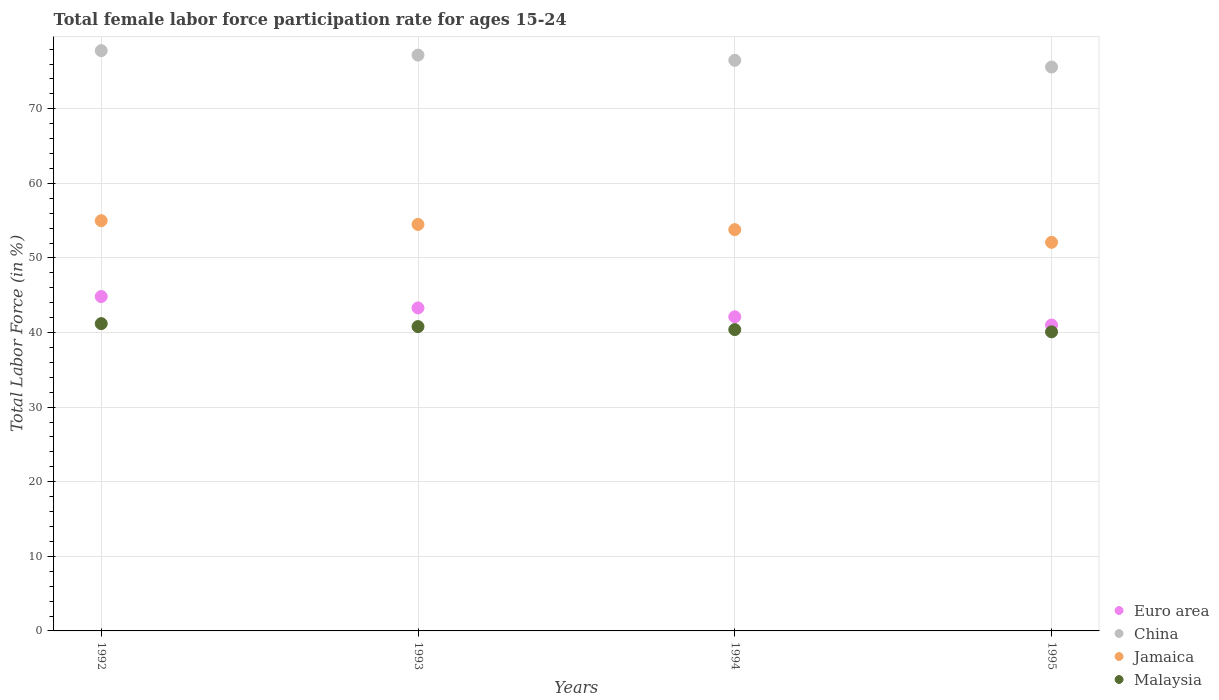What is the female labor force participation rate in China in 1994?
Ensure brevity in your answer.  76.5. Across all years, what is the maximum female labor force participation rate in China?
Offer a very short reply. 77.8. Across all years, what is the minimum female labor force participation rate in Euro area?
Offer a very short reply. 41.01. In which year was the female labor force participation rate in Euro area minimum?
Provide a succinct answer. 1995. What is the total female labor force participation rate in China in the graph?
Offer a very short reply. 307.1. What is the difference between the female labor force participation rate in Jamaica in 1994 and that in 1995?
Make the answer very short. 1.7. What is the difference between the female labor force participation rate in Euro area in 1993 and the female labor force participation rate in China in 1992?
Give a very brief answer. -34.49. What is the average female labor force participation rate in Jamaica per year?
Provide a succinct answer. 53.85. In the year 1992, what is the difference between the female labor force participation rate in Jamaica and female labor force participation rate in China?
Offer a very short reply. -22.8. In how many years, is the female labor force participation rate in China greater than 42 %?
Your response must be concise. 4. What is the ratio of the female labor force participation rate in Euro area in 1993 to that in 1994?
Your response must be concise. 1.03. Is the difference between the female labor force participation rate in Jamaica in 1993 and 1994 greater than the difference between the female labor force participation rate in China in 1993 and 1994?
Your answer should be very brief. Yes. What is the difference between the highest and the second highest female labor force participation rate in Euro area?
Make the answer very short. 1.52. What is the difference between the highest and the lowest female labor force participation rate in Euro area?
Offer a very short reply. 3.82. In how many years, is the female labor force participation rate in Jamaica greater than the average female labor force participation rate in Jamaica taken over all years?
Your answer should be compact. 2. Is the sum of the female labor force participation rate in China in 1994 and 1995 greater than the maximum female labor force participation rate in Malaysia across all years?
Keep it short and to the point. Yes. Is it the case that in every year, the sum of the female labor force participation rate in Euro area and female labor force participation rate in China  is greater than the sum of female labor force participation rate in Jamaica and female labor force participation rate in Malaysia?
Your response must be concise. No. Is the female labor force participation rate in Malaysia strictly greater than the female labor force participation rate in Euro area over the years?
Your answer should be very brief. No. How many years are there in the graph?
Provide a succinct answer. 4. What is the difference between two consecutive major ticks on the Y-axis?
Your answer should be compact. 10. Where does the legend appear in the graph?
Ensure brevity in your answer.  Bottom right. How are the legend labels stacked?
Provide a succinct answer. Vertical. What is the title of the graph?
Keep it short and to the point. Total female labor force participation rate for ages 15-24. Does "Cote d'Ivoire" appear as one of the legend labels in the graph?
Give a very brief answer. No. What is the Total Labor Force (in %) of Euro area in 1992?
Your answer should be very brief. 44.83. What is the Total Labor Force (in %) in China in 1992?
Provide a short and direct response. 77.8. What is the Total Labor Force (in %) in Malaysia in 1992?
Provide a short and direct response. 41.2. What is the Total Labor Force (in %) in Euro area in 1993?
Your answer should be very brief. 43.31. What is the Total Labor Force (in %) in China in 1993?
Keep it short and to the point. 77.2. What is the Total Labor Force (in %) of Jamaica in 1993?
Your answer should be compact. 54.5. What is the Total Labor Force (in %) of Malaysia in 1993?
Make the answer very short. 40.8. What is the Total Labor Force (in %) in Euro area in 1994?
Your response must be concise. 42.11. What is the Total Labor Force (in %) in China in 1994?
Provide a succinct answer. 76.5. What is the Total Labor Force (in %) of Jamaica in 1994?
Your answer should be very brief. 53.8. What is the Total Labor Force (in %) in Malaysia in 1994?
Keep it short and to the point. 40.4. What is the Total Labor Force (in %) in Euro area in 1995?
Offer a very short reply. 41.01. What is the Total Labor Force (in %) in China in 1995?
Your response must be concise. 75.6. What is the Total Labor Force (in %) in Jamaica in 1995?
Offer a terse response. 52.1. What is the Total Labor Force (in %) in Malaysia in 1995?
Provide a succinct answer. 40.1. Across all years, what is the maximum Total Labor Force (in %) in Euro area?
Your answer should be very brief. 44.83. Across all years, what is the maximum Total Labor Force (in %) in China?
Your answer should be very brief. 77.8. Across all years, what is the maximum Total Labor Force (in %) in Malaysia?
Make the answer very short. 41.2. Across all years, what is the minimum Total Labor Force (in %) in Euro area?
Your answer should be very brief. 41.01. Across all years, what is the minimum Total Labor Force (in %) of China?
Your answer should be compact. 75.6. Across all years, what is the minimum Total Labor Force (in %) in Jamaica?
Provide a short and direct response. 52.1. Across all years, what is the minimum Total Labor Force (in %) of Malaysia?
Keep it short and to the point. 40.1. What is the total Total Labor Force (in %) of Euro area in the graph?
Ensure brevity in your answer.  171.26. What is the total Total Labor Force (in %) in China in the graph?
Your answer should be very brief. 307.1. What is the total Total Labor Force (in %) in Jamaica in the graph?
Make the answer very short. 215.4. What is the total Total Labor Force (in %) of Malaysia in the graph?
Your answer should be very brief. 162.5. What is the difference between the Total Labor Force (in %) of Euro area in 1992 and that in 1993?
Provide a short and direct response. 1.52. What is the difference between the Total Labor Force (in %) in China in 1992 and that in 1993?
Ensure brevity in your answer.  0.6. What is the difference between the Total Labor Force (in %) of Jamaica in 1992 and that in 1993?
Give a very brief answer. 0.5. What is the difference between the Total Labor Force (in %) of Malaysia in 1992 and that in 1993?
Offer a very short reply. 0.4. What is the difference between the Total Labor Force (in %) of Euro area in 1992 and that in 1994?
Give a very brief answer. 2.72. What is the difference between the Total Labor Force (in %) in China in 1992 and that in 1994?
Ensure brevity in your answer.  1.3. What is the difference between the Total Labor Force (in %) in Jamaica in 1992 and that in 1994?
Provide a succinct answer. 1.2. What is the difference between the Total Labor Force (in %) in Euro area in 1992 and that in 1995?
Make the answer very short. 3.82. What is the difference between the Total Labor Force (in %) in China in 1992 and that in 1995?
Provide a short and direct response. 2.2. What is the difference between the Total Labor Force (in %) in Euro area in 1993 and that in 1994?
Give a very brief answer. 1.19. What is the difference between the Total Labor Force (in %) of China in 1993 and that in 1994?
Offer a very short reply. 0.7. What is the difference between the Total Labor Force (in %) of Jamaica in 1993 and that in 1994?
Your response must be concise. 0.7. What is the difference between the Total Labor Force (in %) in Malaysia in 1993 and that in 1994?
Keep it short and to the point. 0.4. What is the difference between the Total Labor Force (in %) in Euro area in 1993 and that in 1995?
Your answer should be compact. 2.29. What is the difference between the Total Labor Force (in %) of Jamaica in 1993 and that in 1995?
Keep it short and to the point. 2.4. What is the difference between the Total Labor Force (in %) of Euro area in 1994 and that in 1995?
Keep it short and to the point. 1.1. What is the difference between the Total Labor Force (in %) of China in 1994 and that in 1995?
Offer a very short reply. 0.9. What is the difference between the Total Labor Force (in %) of Malaysia in 1994 and that in 1995?
Make the answer very short. 0.3. What is the difference between the Total Labor Force (in %) in Euro area in 1992 and the Total Labor Force (in %) in China in 1993?
Keep it short and to the point. -32.37. What is the difference between the Total Labor Force (in %) in Euro area in 1992 and the Total Labor Force (in %) in Jamaica in 1993?
Give a very brief answer. -9.67. What is the difference between the Total Labor Force (in %) of Euro area in 1992 and the Total Labor Force (in %) of Malaysia in 1993?
Your answer should be very brief. 4.03. What is the difference between the Total Labor Force (in %) of China in 1992 and the Total Labor Force (in %) of Jamaica in 1993?
Provide a short and direct response. 23.3. What is the difference between the Total Labor Force (in %) in China in 1992 and the Total Labor Force (in %) in Malaysia in 1993?
Your answer should be very brief. 37. What is the difference between the Total Labor Force (in %) of Euro area in 1992 and the Total Labor Force (in %) of China in 1994?
Your response must be concise. -31.67. What is the difference between the Total Labor Force (in %) of Euro area in 1992 and the Total Labor Force (in %) of Jamaica in 1994?
Offer a very short reply. -8.97. What is the difference between the Total Labor Force (in %) in Euro area in 1992 and the Total Labor Force (in %) in Malaysia in 1994?
Provide a short and direct response. 4.43. What is the difference between the Total Labor Force (in %) in China in 1992 and the Total Labor Force (in %) in Jamaica in 1994?
Offer a terse response. 24. What is the difference between the Total Labor Force (in %) in China in 1992 and the Total Labor Force (in %) in Malaysia in 1994?
Provide a succinct answer. 37.4. What is the difference between the Total Labor Force (in %) in Euro area in 1992 and the Total Labor Force (in %) in China in 1995?
Your response must be concise. -30.77. What is the difference between the Total Labor Force (in %) in Euro area in 1992 and the Total Labor Force (in %) in Jamaica in 1995?
Provide a succinct answer. -7.27. What is the difference between the Total Labor Force (in %) of Euro area in 1992 and the Total Labor Force (in %) of Malaysia in 1995?
Provide a succinct answer. 4.73. What is the difference between the Total Labor Force (in %) in China in 1992 and the Total Labor Force (in %) in Jamaica in 1995?
Offer a terse response. 25.7. What is the difference between the Total Labor Force (in %) in China in 1992 and the Total Labor Force (in %) in Malaysia in 1995?
Ensure brevity in your answer.  37.7. What is the difference between the Total Labor Force (in %) of Euro area in 1993 and the Total Labor Force (in %) of China in 1994?
Ensure brevity in your answer.  -33.19. What is the difference between the Total Labor Force (in %) in Euro area in 1993 and the Total Labor Force (in %) in Jamaica in 1994?
Your answer should be compact. -10.49. What is the difference between the Total Labor Force (in %) of Euro area in 1993 and the Total Labor Force (in %) of Malaysia in 1994?
Provide a short and direct response. 2.91. What is the difference between the Total Labor Force (in %) in China in 1993 and the Total Labor Force (in %) in Jamaica in 1994?
Ensure brevity in your answer.  23.4. What is the difference between the Total Labor Force (in %) in China in 1993 and the Total Labor Force (in %) in Malaysia in 1994?
Your answer should be very brief. 36.8. What is the difference between the Total Labor Force (in %) in Euro area in 1993 and the Total Labor Force (in %) in China in 1995?
Offer a terse response. -32.29. What is the difference between the Total Labor Force (in %) in Euro area in 1993 and the Total Labor Force (in %) in Jamaica in 1995?
Ensure brevity in your answer.  -8.79. What is the difference between the Total Labor Force (in %) of Euro area in 1993 and the Total Labor Force (in %) of Malaysia in 1995?
Offer a very short reply. 3.21. What is the difference between the Total Labor Force (in %) of China in 1993 and the Total Labor Force (in %) of Jamaica in 1995?
Keep it short and to the point. 25.1. What is the difference between the Total Labor Force (in %) of China in 1993 and the Total Labor Force (in %) of Malaysia in 1995?
Make the answer very short. 37.1. What is the difference between the Total Labor Force (in %) in Jamaica in 1993 and the Total Labor Force (in %) in Malaysia in 1995?
Make the answer very short. 14.4. What is the difference between the Total Labor Force (in %) of Euro area in 1994 and the Total Labor Force (in %) of China in 1995?
Provide a short and direct response. -33.49. What is the difference between the Total Labor Force (in %) in Euro area in 1994 and the Total Labor Force (in %) in Jamaica in 1995?
Provide a short and direct response. -9.99. What is the difference between the Total Labor Force (in %) of Euro area in 1994 and the Total Labor Force (in %) of Malaysia in 1995?
Your answer should be compact. 2.01. What is the difference between the Total Labor Force (in %) in China in 1994 and the Total Labor Force (in %) in Jamaica in 1995?
Give a very brief answer. 24.4. What is the difference between the Total Labor Force (in %) in China in 1994 and the Total Labor Force (in %) in Malaysia in 1995?
Make the answer very short. 36.4. What is the difference between the Total Labor Force (in %) of Jamaica in 1994 and the Total Labor Force (in %) of Malaysia in 1995?
Your answer should be very brief. 13.7. What is the average Total Labor Force (in %) of Euro area per year?
Provide a short and direct response. 42.82. What is the average Total Labor Force (in %) of China per year?
Offer a very short reply. 76.78. What is the average Total Labor Force (in %) in Jamaica per year?
Your response must be concise. 53.85. What is the average Total Labor Force (in %) of Malaysia per year?
Make the answer very short. 40.62. In the year 1992, what is the difference between the Total Labor Force (in %) in Euro area and Total Labor Force (in %) in China?
Ensure brevity in your answer.  -32.97. In the year 1992, what is the difference between the Total Labor Force (in %) in Euro area and Total Labor Force (in %) in Jamaica?
Keep it short and to the point. -10.17. In the year 1992, what is the difference between the Total Labor Force (in %) of Euro area and Total Labor Force (in %) of Malaysia?
Offer a very short reply. 3.63. In the year 1992, what is the difference between the Total Labor Force (in %) of China and Total Labor Force (in %) of Jamaica?
Offer a very short reply. 22.8. In the year 1992, what is the difference between the Total Labor Force (in %) in China and Total Labor Force (in %) in Malaysia?
Provide a succinct answer. 36.6. In the year 1993, what is the difference between the Total Labor Force (in %) in Euro area and Total Labor Force (in %) in China?
Your answer should be very brief. -33.89. In the year 1993, what is the difference between the Total Labor Force (in %) of Euro area and Total Labor Force (in %) of Jamaica?
Keep it short and to the point. -11.19. In the year 1993, what is the difference between the Total Labor Force (in %) in Euro area and Total Labor Force (in %) in Malaysia?
Provide a short and direct response. 2.51. In the year 1993, what is the difference between the Total Labor Force (in %) in China and Total Labor Force (in %) in Jamaica?
Ensure brevity in your answer.  22.7. In the year 1993, what is the difference between the Total Labor Force (in %) of China and Total Labor Force (in %) of Malaysia?
Give a very brief answer. 36.4. In the year 1993, what is the difference between the Total Labor Force (in %) of Jamaica and Total Labor Force (in %) of Malaysia?
Give a very brief answer. 13.7. In the year 1994, what is the difference between the Total Labor Force (in %) of Euro area and Total Labor Force (in %) of China?
Keep it short and to the point. -34.39. In the year 1994, what is the difference between the Total Labor Force (in %) in Euro area and Total Labor Force (in %) in Jamaica?
Make the answer very short. -11.69. In the year 1994, what is the difference between the Total Labor Force (in %) in Euro area and Total Labor Force (in %) in Malaysia?
Your response must be concise. 1.71. In the year 1994, what is the difference between the Total Labor Force (in %) of China and Total Labor Force (in %) of Jamaica?
Keep it short and to the point. 22.7. In the year 1994, what is the difference between the Total Labor Force (in %) of China and Total Labor Force (in %) of Malaysia?
Your answer should be compact. 36.1. In the year 1995, what is the difference between the Total Labor Force (in %) in Euro area and Total Labor Force (in %) in China?
Give a very brief answer. -34.59. In the year 1995, what is the difference between the Total Labor Force (in %) of Euro area and Total Labor Force (in %) of Jamaica?
Offer a terse response. -11.09. In the year 1995, what is the difference between the Total Labor Force (in %) in Euro area and Total Labor Force (in %) in Malaysia?
Your answer should be compact. 0.91. In the year 1995, what is the difference between the Total Labor Force (in %) of China and Total Labor Force (in %) of Malaysia?
Your response must be concise. 35.5. In the year 1995, what is the difference between the Total Labor Force (in %) in Jamaica and Total Labor Force (in %) in Malaysia?
Provide a short and direct response. 12. What is the ratio of the Total Labor Force (in %) of Euro area in 1992 to that in 1993?
Keep it short and to the point. 1.04. What is the ratio of the Total Labor Force (in %) of China in 1992 to that in 1993?
Provide a short and direct response. 1.01. What is the ratio of the Total Labor Force (in %) of Jamaica in 1992 to that in 1993?
Offer a very short reply. 1.01. What is the ratio of the Total Labor Force (in %) in Malaysia in 1992 to that in 1993?
Offer a very short reply. 1.01. What is the ratio of the Total Labor Force (in %) of Euro area in 1992 to that in 1994?
Your answer should be very brief. 1.06. What is the ratio of the Total Labor Force (in %) in Jamaica in 1992 to that in 1994?
Make the answer very short. 1.02. What is the ratio of the Total Labor Force (in %) in Malaysia in 1992 to that in 1994?
Your answer should be compact. 1.02. What is the ratio of the Total Labor Force (in %) in Euro area in 1992 to that in 1995?
Give a very brief answer. 1.09. What is the ratio of the Total Labor Force (in %) of China in 1992 to that in 1995?
Keep it short and to the point. 1.03. What is the ratio of the Total Labor Force (in %) of Jamaica in 1992 to that in 1995?
Provide a succinct answer. 1.06. What is the ratio of the Total Labor Force (in %) of Malaysia in 1992 to that in 1995?
Your answer should be compact. 1.03. What is the ratio of the Total Labor Force (in %) in Euro area in 1993 to that in 1994?
Offer a terse response. 1.03. What is the ratio of the Total Labor Force (in %) in China in 1993 to that in 1994?
Make the answer very short. 1.01. What is the ratio of the Total Labor Force (in %) in Malaysia in 1993 to that in 1994?
Ensure brevity in your answer.  1.01. What is the ratio of the Total Labor Force (in %) in Euro area in 1993 to that in 1995?
Keep it short and to the point. 1.06. What is the ratio of the Total Labor Force (in %) in China in 1993 to that in 1995?
Make the answer very short. 1.02. What is the ratio of the Total Labor Force (in %) in Jamaica in 1993 to that in 1995?
Your answer should be compact. 1.05. What is the ratio of the Total Labor Force (in %) in Malaysia in 1993 to that in 1995?
Provide a succinct answer. 1.02. What is the ratio of the Total Labor Force (in %) of Euro area in 1994 to that in 1995?
Your response must be concise. 1.03. What is the ratio of the Total Labor Force (in %) of China in 1994 to that in 1995?
Offer a very short reply. 1.01. What is the ratio of the Total Labor Force (in %) of Jamaica in 1994 to that in 1995?
Offer a very short reply. 1.03. What is the ratio of the Total Labor Force (in %) of Malaysia in 1994 to that in 1995?
Ensure brevity in your answer.  1.01. What is the difference between the highest and the second highest Total Labor Force (in %) of Euro area?
Offer a very short reply. 1.52. What is the difference between the highest and the second highest Total Labor Force (in %) in China?
Give a very brief answer. 0.6. What is the difference between the highest and the second highest Total Labor Force (in %) of Jamaica?
Keep it short and to the point. 0.5. What is the difference between the highest and the lowest Total Labor Force (in %) of Euro area?
Provide a short and direct response. 3.82. What is the difference between the highest and the lowest Total Labor Force (in %) of China?
Offer a terse response. 2.2. What is the difference between the highest and the lowest Total Labor Force (in %) in Jamaica?
Offer a very short reply. 2.9. What is the difference between the highest and the lowest Total Labor Force (in %) in Malaysia?
Give a very brief answer. 1.1. 